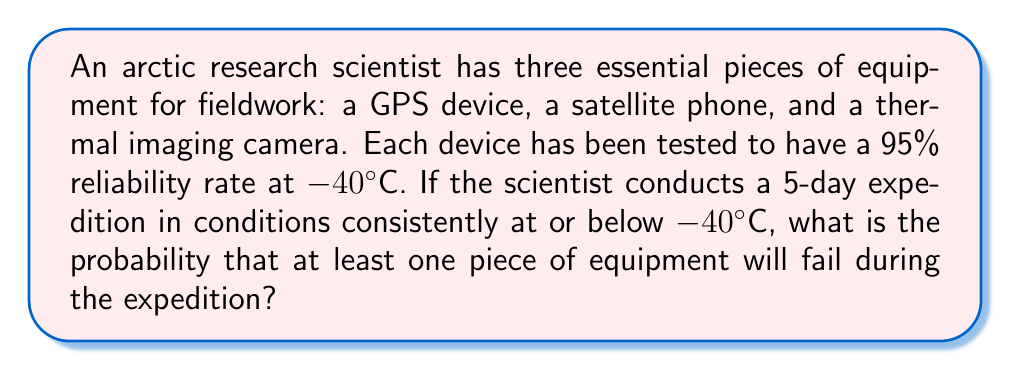Could you help me with this problem? Let's approach this step-by-step:

1) First, we need to calculate the probability of each device working for the entire 5-day period.
   For each device: $P(\text{working for 5 days}) = (0.95)^5 = 0.7738$

2) Now, we can calculate the probability of all devices working for the entire period:
   $P(\text{all working}) = (0.7738)^3 = 0.4633$

3) The probability of at least one piece of equipment failing is the complement of all equipment working:
   $P(\text{at least one fails}) = 1 - P(\text{all working})$
   $= 1 - 0.4633 = 0.5367$

4) To express this as a percentage:
   $0.5367 \times 100\% = 53.67\%$

Therefore, there is a 53.67% chance that at least one piece of equipment will fail during the 5-day expedition in extreme cold conditions.
Answer: 53.67% 